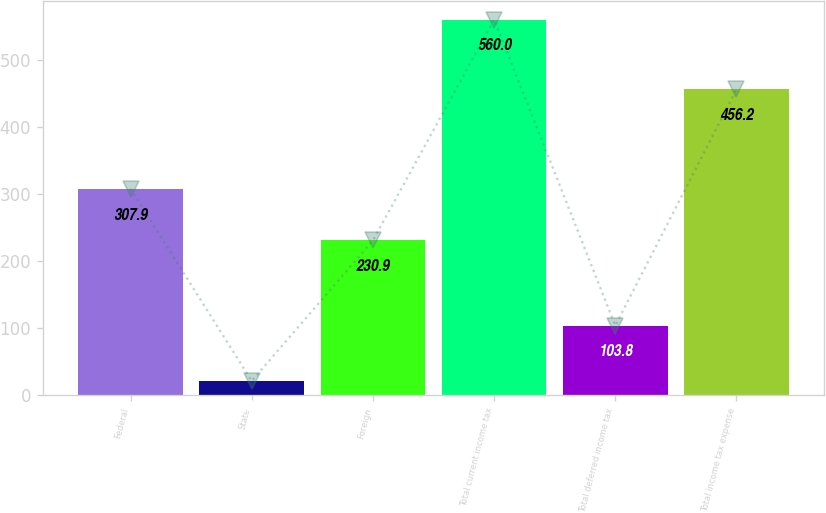<chart> <loc_0><loc_0><loc_500><loc_500><bar_chart><fcel>Federal<fcel>State<fcel>Foreign<fcel>Total current income tax<fcel>Total deferred income tax<fcel>Total income tax expense<nl><fcel>307.9<fcel>21.2<fcel>230.9<fcel>560<fcel>103.8<fcel>456.2<nl></chart> 